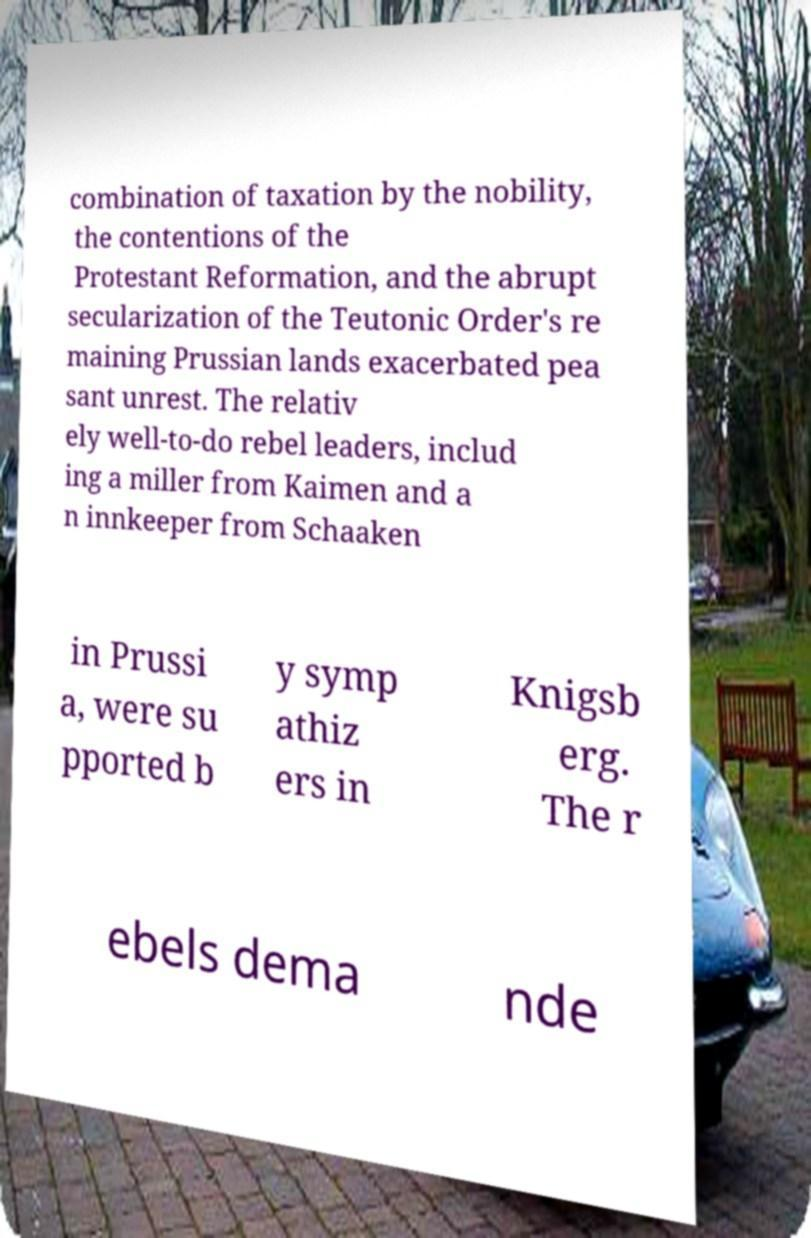Can you accurately transcribe the text from the provided image for me? combination of taxation by the nobility, the contentions of the Protestant Reformation, and the abrupt secularization of the Teutonic Order's re maining Prussian lands exacerbated pea sant unrest. The relativ ely well-to-do rebel leaders, includ ing a miller from Kaimen and a n innkeeper from Schaaken in Prussi a, were su pported b y symp athiz ers in Knigsb erg. The r ebels dema nde 